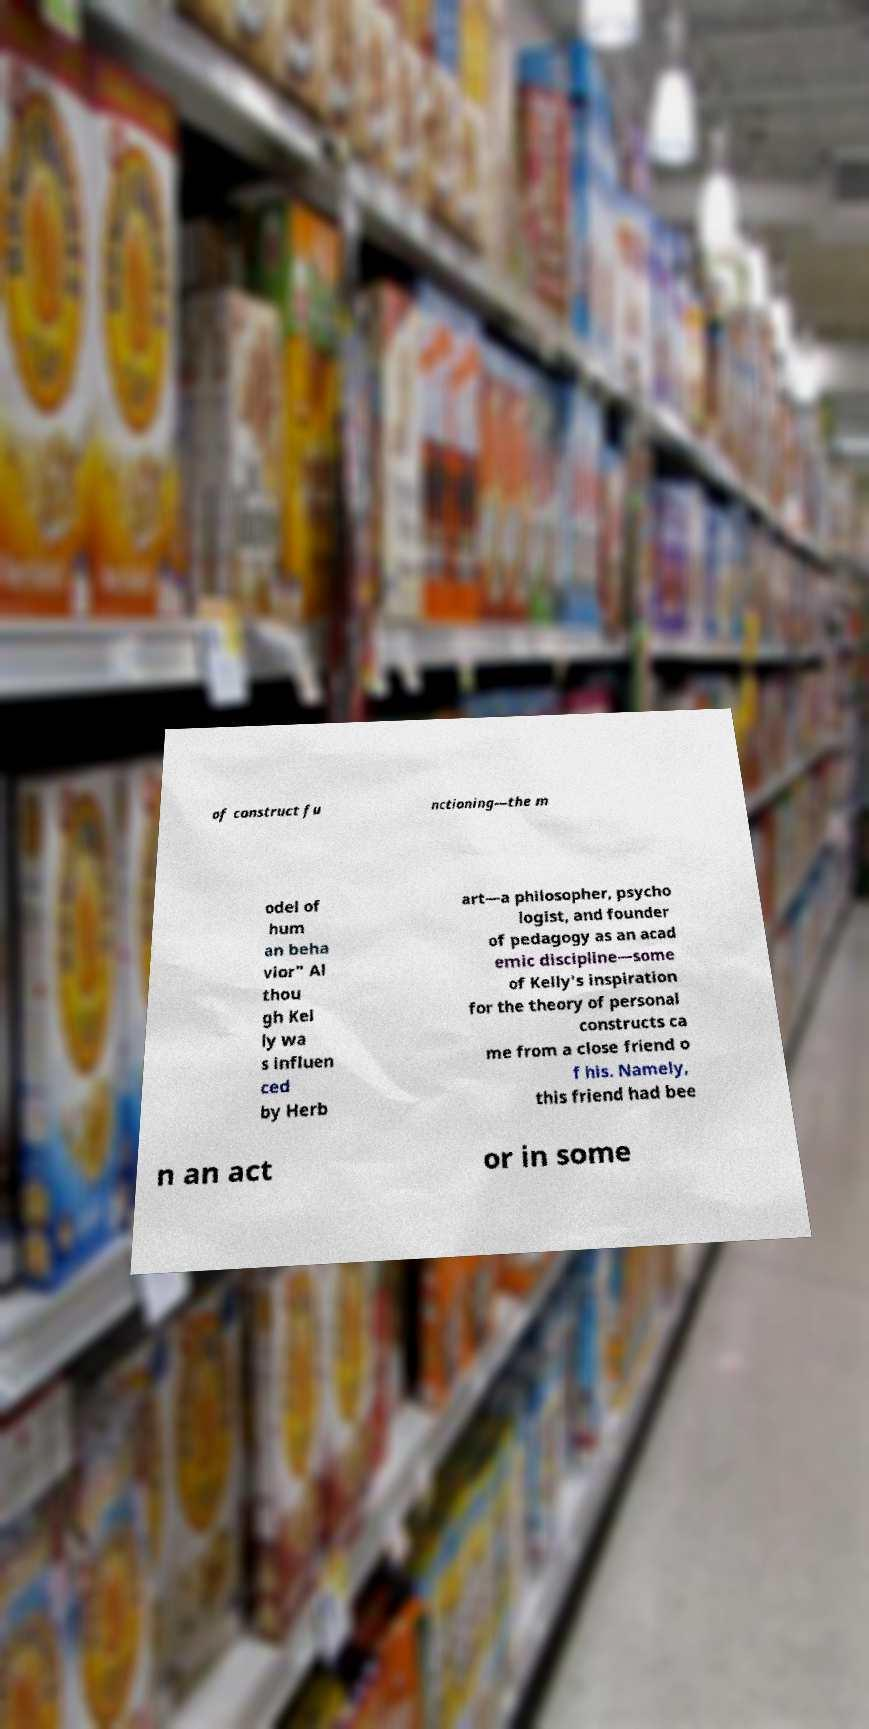There's text embedded in this image that I need extracted. Can you transcribe it verbatim? of construct fu nctioning—the m odel of hum an beha vior" Al thou gh Kel ly wa s influen ced by Herb art—a philosopher, psycho logist, and founder of pedagogy as an acad emic discipline—some of Kelly's inspiration for the theory of personal constructs ca me from a close friend o f his. Namely, this friend had bee n an act or in some 